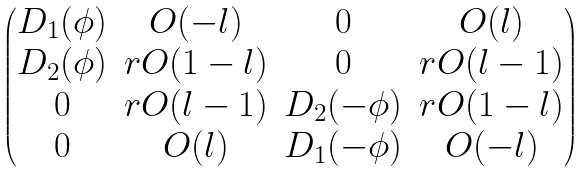<formula> <loc_0><loc_0><loc_500><loc_500>\begin{pmatrix} D _ { 1 } ( \phi ) & O ( - l ) & 0 & O ( l ) \\ D _ { 2 } ( \phi ) & r O ( 1 - l ) & 0 & r O ( l - 1 ) \\ 0 & r O ( l - 1 ) & D _ { 2 } ( - \phi ) & r O ( 1 - l ) \\ 0 & O ( l ) & D _ { 1 } ( - \phi ) & O ( - l ) \end{pmatrix}</formula> 